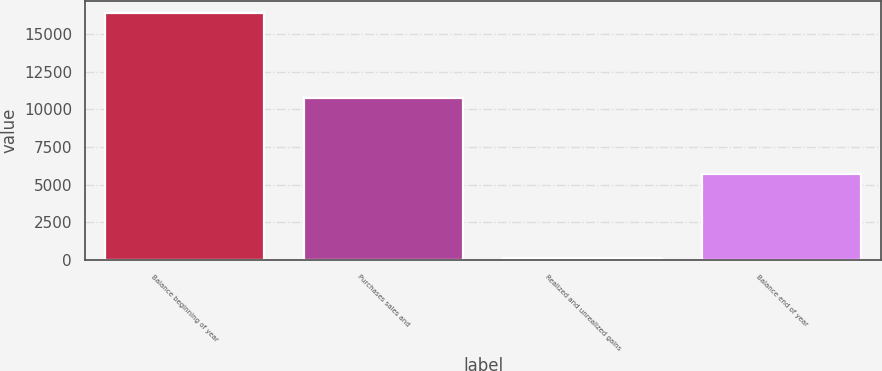Convert chart. <chart><loc_0><loc_0><loc_500><loc_500><bar_chart><fcel>Balance beginning of year<fcel>Purchases sales and<fcel>Realized and unrealized gains<fcel>Balance end of year<nl><fcel>16372<fcel>10788<fcel>131<fcel>5715<nl></chart> 